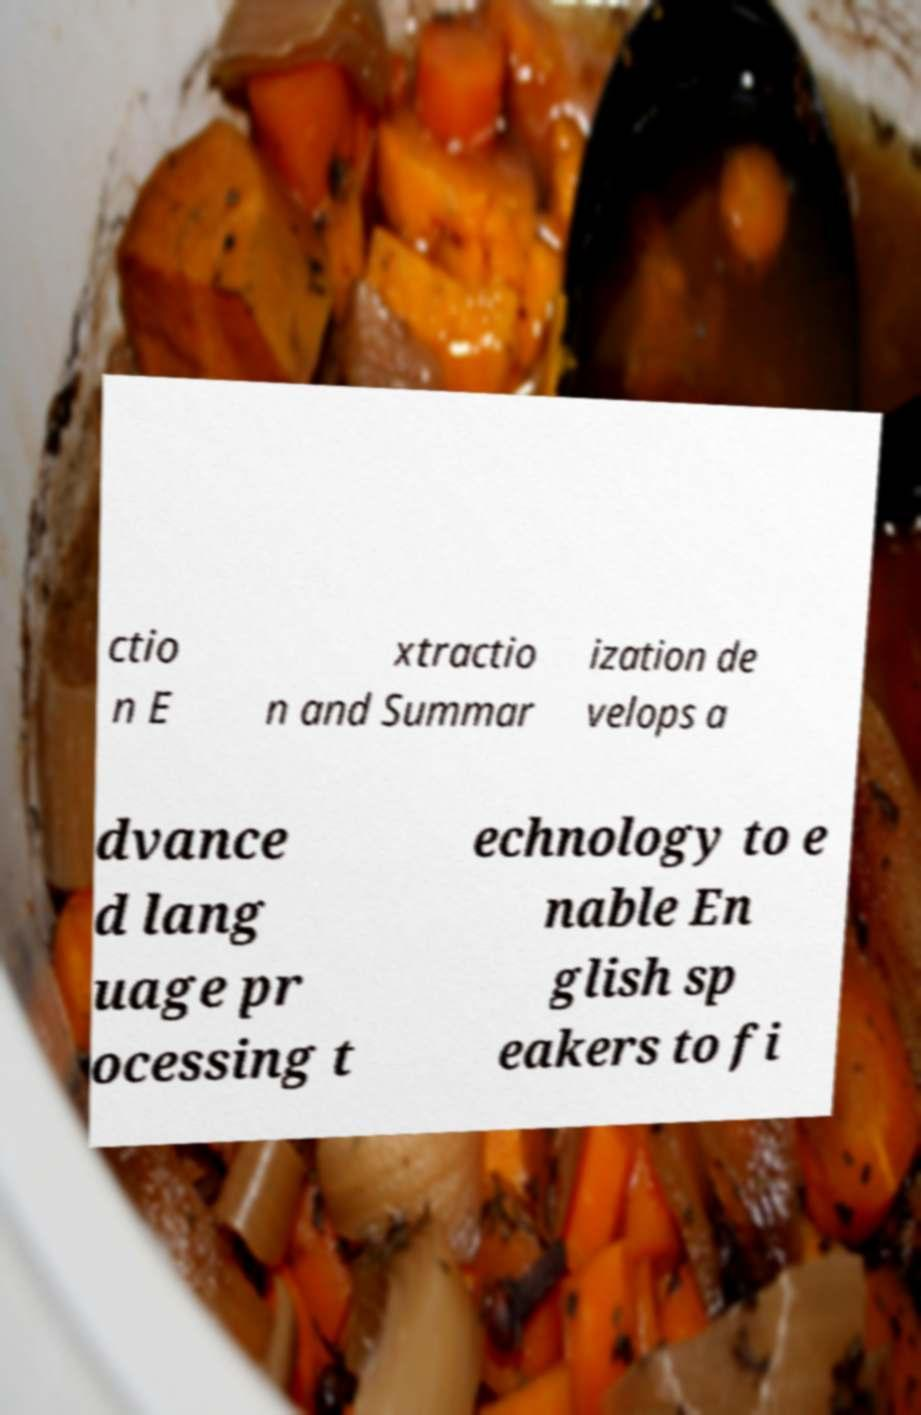What messages or text are displayed in this image? I need them in a readable, typed format. ctio n E xtractio n and Summar ization de velops a dvance d lang uage pr ocessing t echnology to e nable En glish sp eakers to fi 